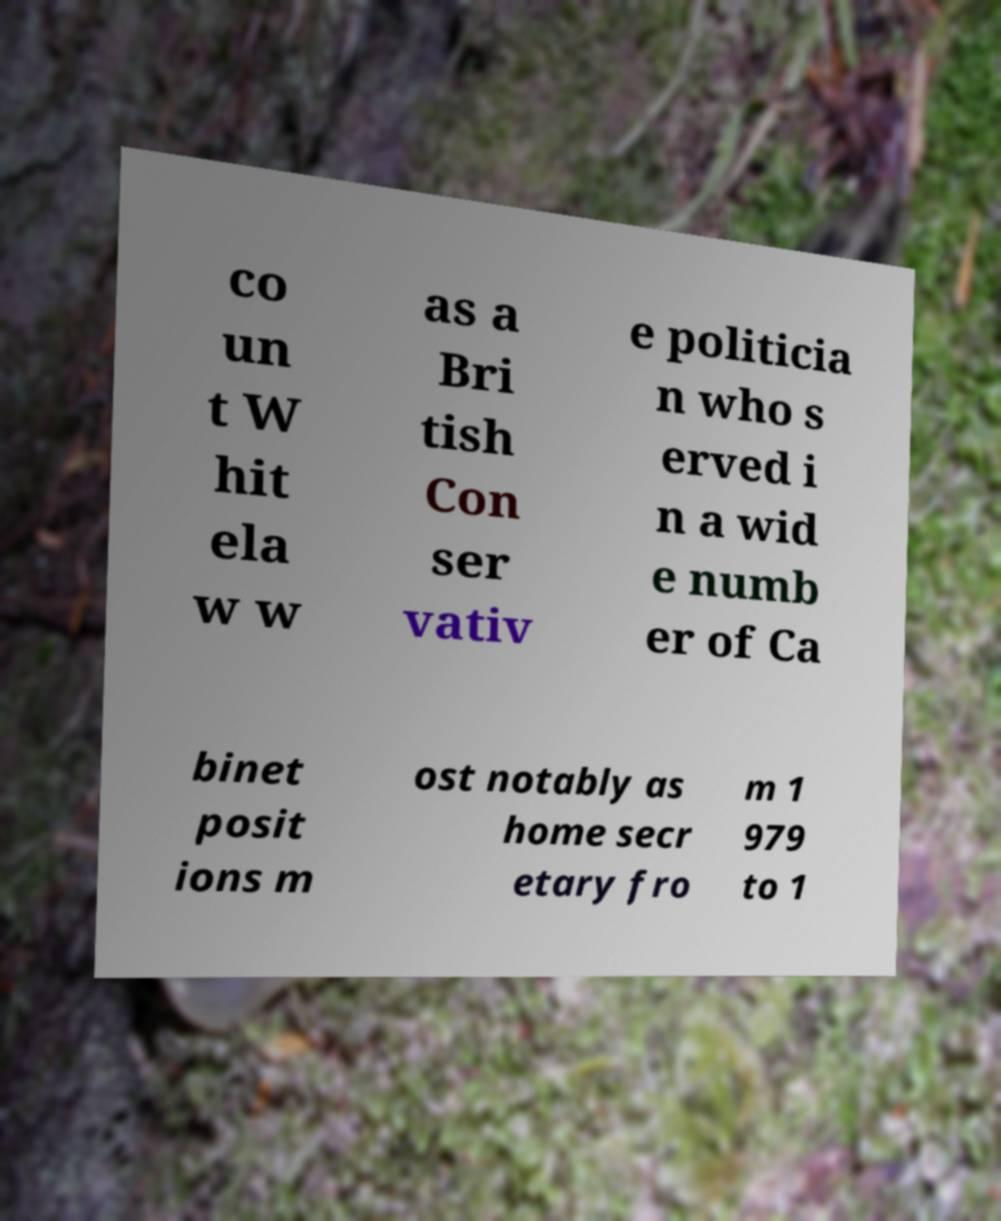What messages or text are displayed in this image? I need them in a readable, typed format. co un t W hit ela w w as a Bri tish Con ser vativ e politicia n who s erved i n a wid e numb er of Ca binet posit ions m ost notably as home secr etary fro m 1 979 to 1 